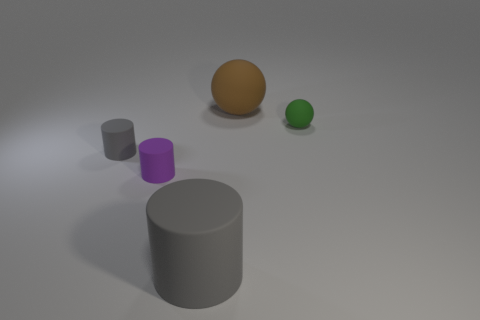Subtract 1 cylinders. How many cylinders are left? 2 Add 1 big gray matte cylinders. How many objects exist? 6 Subtract all cylinders. How many objects are left? 2 Subtract 0 blue spheres. How many objects are left? 5 Subtract all cubes. Subtract all matte cylinders. How many objects are left? 2 Add 2 gray matte cylinders. How many gray matte cylinders are left? 4 Add 3 big gray objects. How many big gray objects exist? 4 